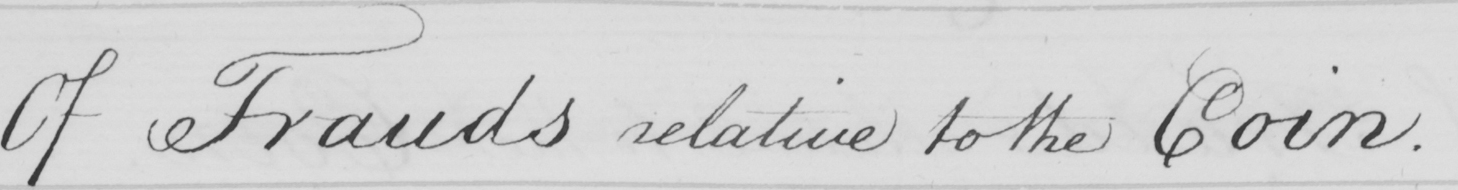Transcribe the text shown in this historical manuscript line. Of Frauds relative to the Coin . 